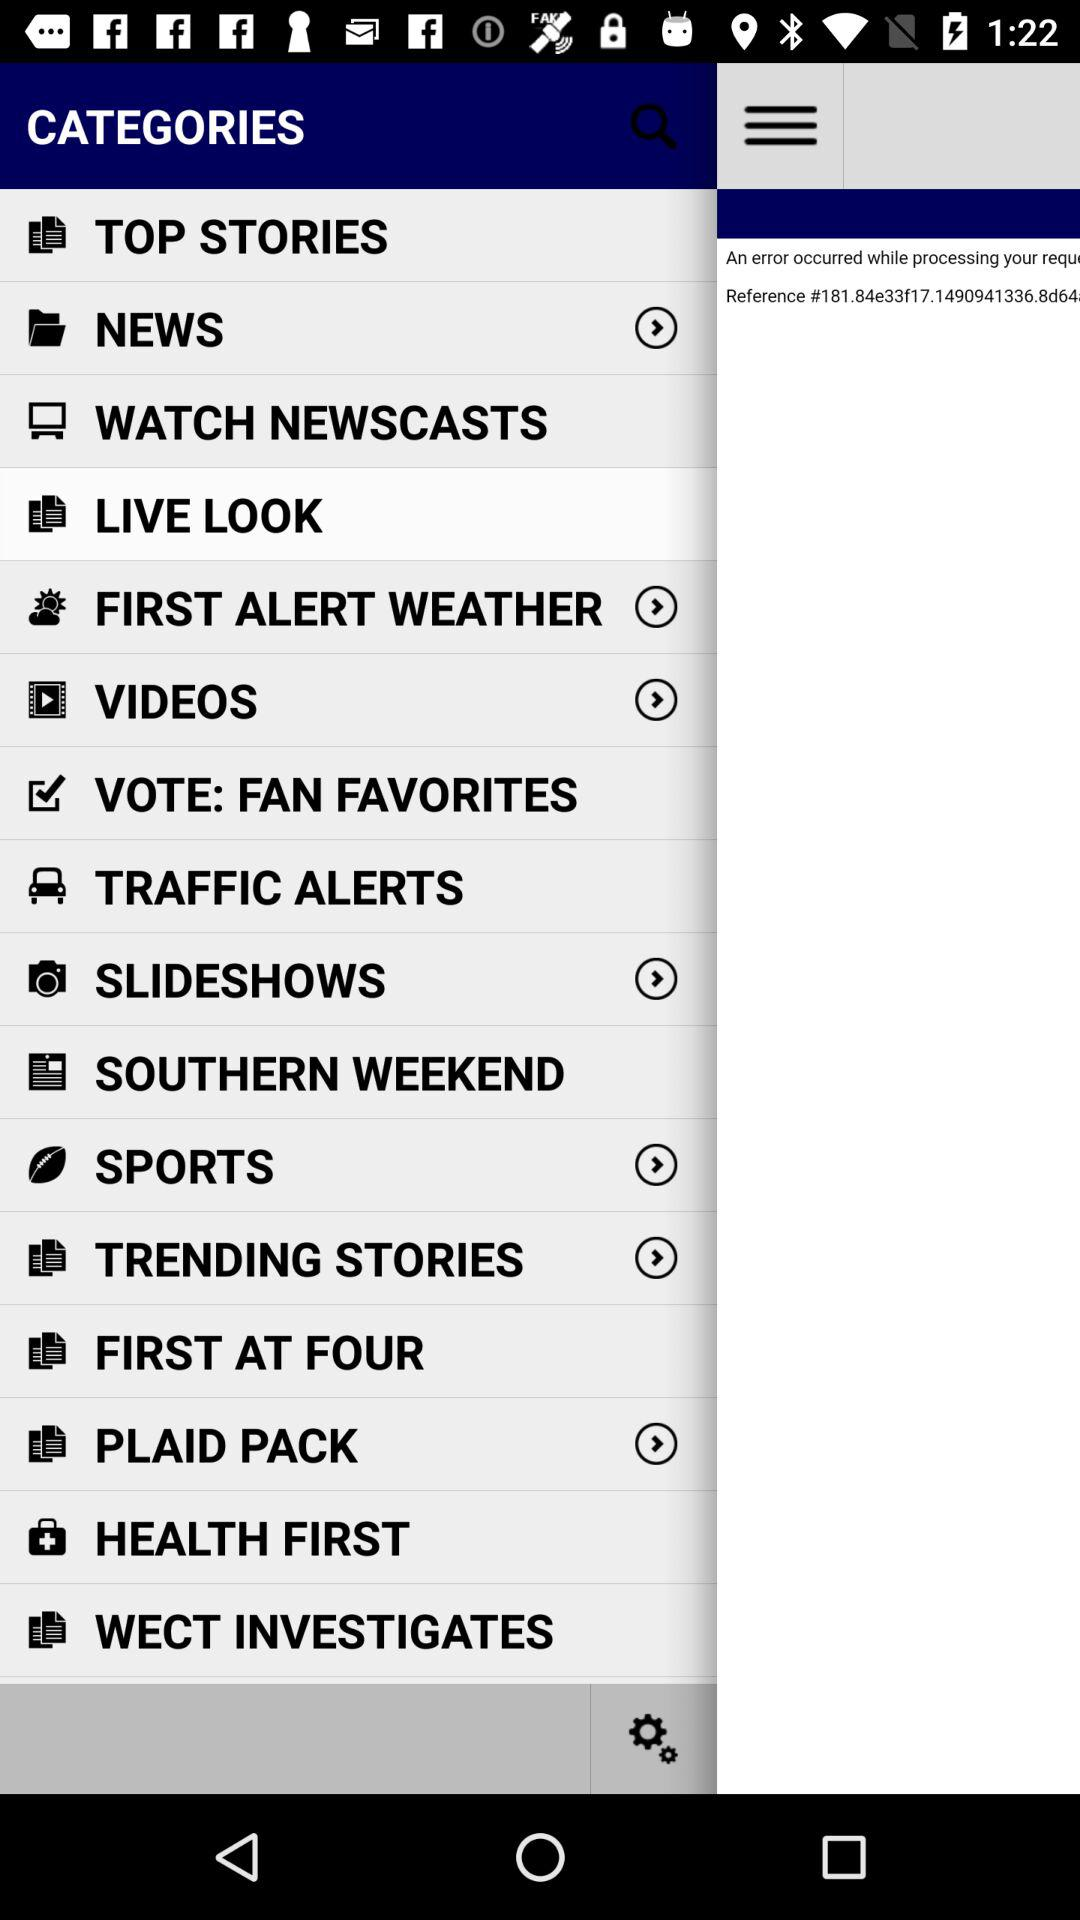What are the available items in the menu? The available items in the menu are "TOP STORIES", "NEWS", "WATCH NEWSCASTS", "LIVE LOOK", "FIRST ALERT WEATHER", "VIDEOS", "VOTE: FAN FAVORITES", "TRAFFIC ALERTS", "SLIDESHOWS", "SOUTHERN WEEKEND", "SPORTS", "TRENDING STORIES", "FIRST AT FOUR", "PLAID PACK", "HEALTH FIRST" and "WECT INVESTIGATES". 